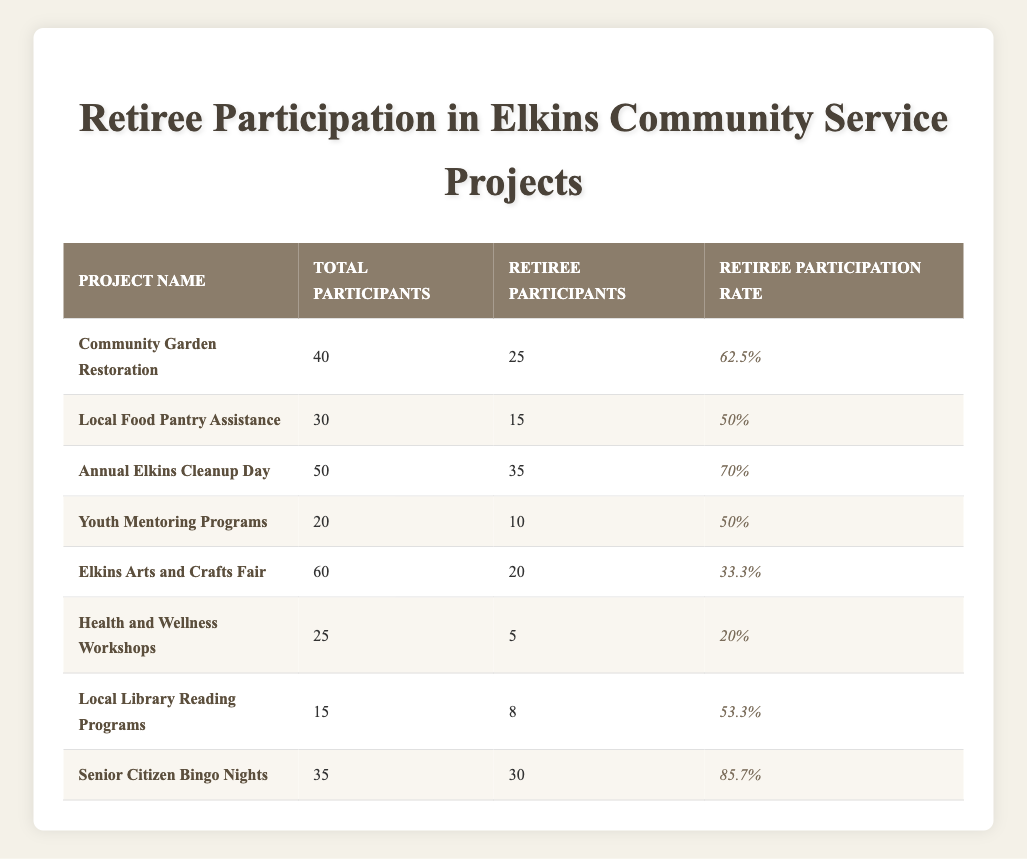What is the project with the highest participation rate among retirees? By examining the "Retiree Participation Rate" column, we find that the "Senior Citizen Bingo Nights" has a participation rate of 85.7%, which is higher than all other projects listed.
Answer: Senior Citizen Bingo Nights How many retirees participated in the "Annual Elkins Cleanup Day"? According to the table, the retirees' participation in the "Annual Elkins Cleanup Day" was recorded as 35.
Answer: 35 What is the average retiree participation rate across all projects? To find the average, we add all the retiree participation rates: 62.5 + 50 + 70 + 50 + 33.3 + 20 + 53.3 + 85.7, which equals 425.8. Dividing this by the number of projects (8) gives us an average of 53.225%.
Answer: 53.225% Did more retirees participate in the "Community Garden Restoration" project than in the "Health and Wellness Workshops"? The table shows that 25 retirees participated in the "Community Garden Restoration" while only 5 participated in the "Health and Wellness Workshops." Therefore, more retirees participated in the former.
Answer: Yes What is the total number of participants (including retirees) in the "Local Food Pantry Assistance" project? The table indicates that the total number of participants in the "Local Food Pantry Assistance" project is 30, as stated in the "Total Participants" column.
Answer: 30 Which project had the lowest number of retiree participation? Looking at the "Retiree Participants" column shows that "Health and Wellness Workshops" had only 5 retirees participating, which is the lowest compared to other projects.
Answer: Health and Wellness Workshops Are retirees more likely to participate in projects that have higher total attendance? To determine this, we can consider the correlation between total participants and retiree participation across the projects. The projects with the highest total participants, like "Annual Elkins Cleanup Day" and "Community Garden Restoration," also have high retiree participation rates, indicating a trend.
Answer: Yes How many retirees participated in the "Elkins Arts and Crafts Fair"? Referring to the table, the number of retirees who participated in the "Elkins Arts and Crafts Fair" is stated as 20.
Answer: 20 